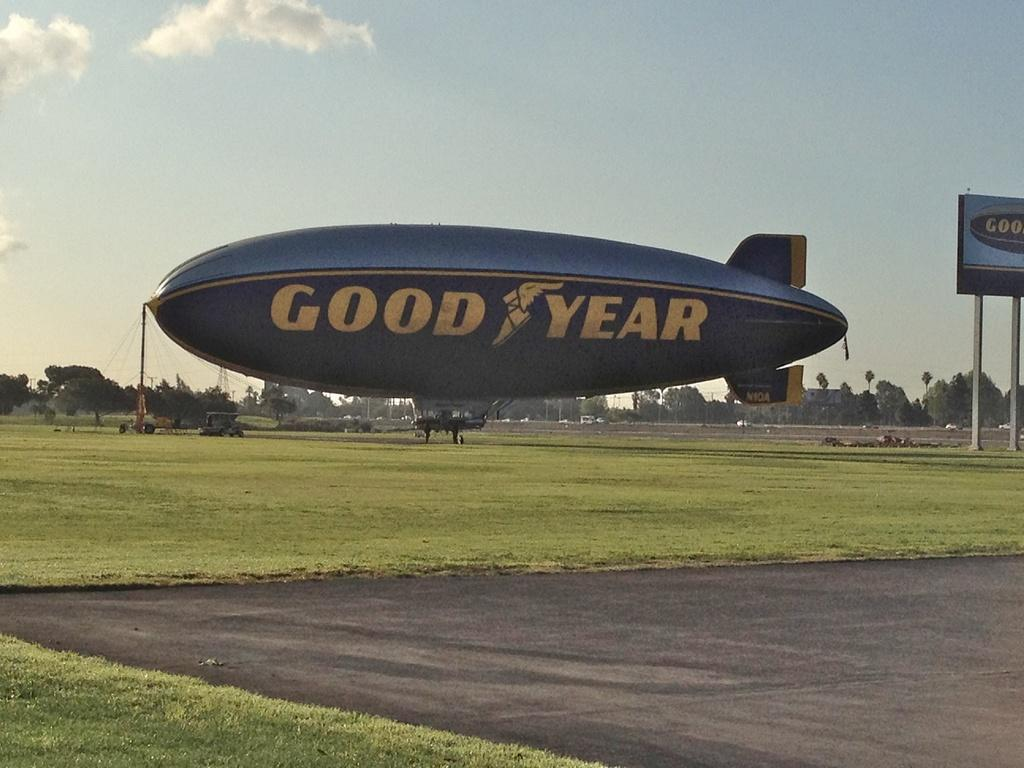What is on the ground in the image? There are advertisements on the ground in the image. What type of transportation can be seen in the image? Motor vehicles are visible in the image. What structures are present in the image? There are poles and towers in the image. What type of vegetation is present in the image? Trees are present in the image. What is visible in the background of the image? The sky is visible in the image, and clouds are present in the sky. Where is the store located in the image? There is no store present in the image. What type of tool does the carpenter use in the image? There is no carpenter present in the image. 